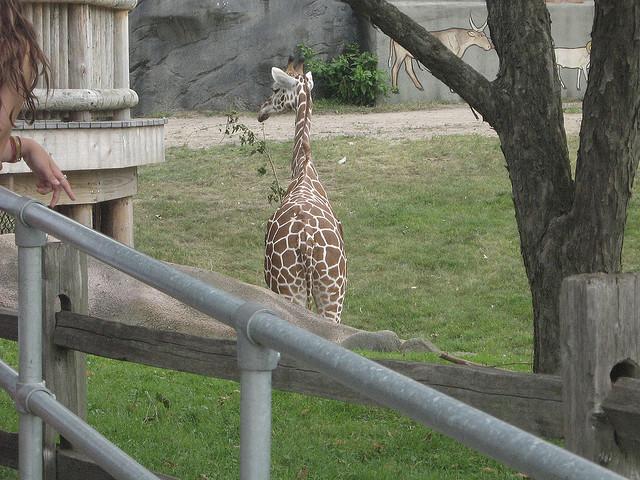Is this giraffe fully grown?
Short answer required. No. What kind of area is the cow in?
Short answer required. Zoo. Is the giraffe facing away from the camera?
Be succinct. Yes. Are the handrails made of steel?
Quick response, please. Yes. 